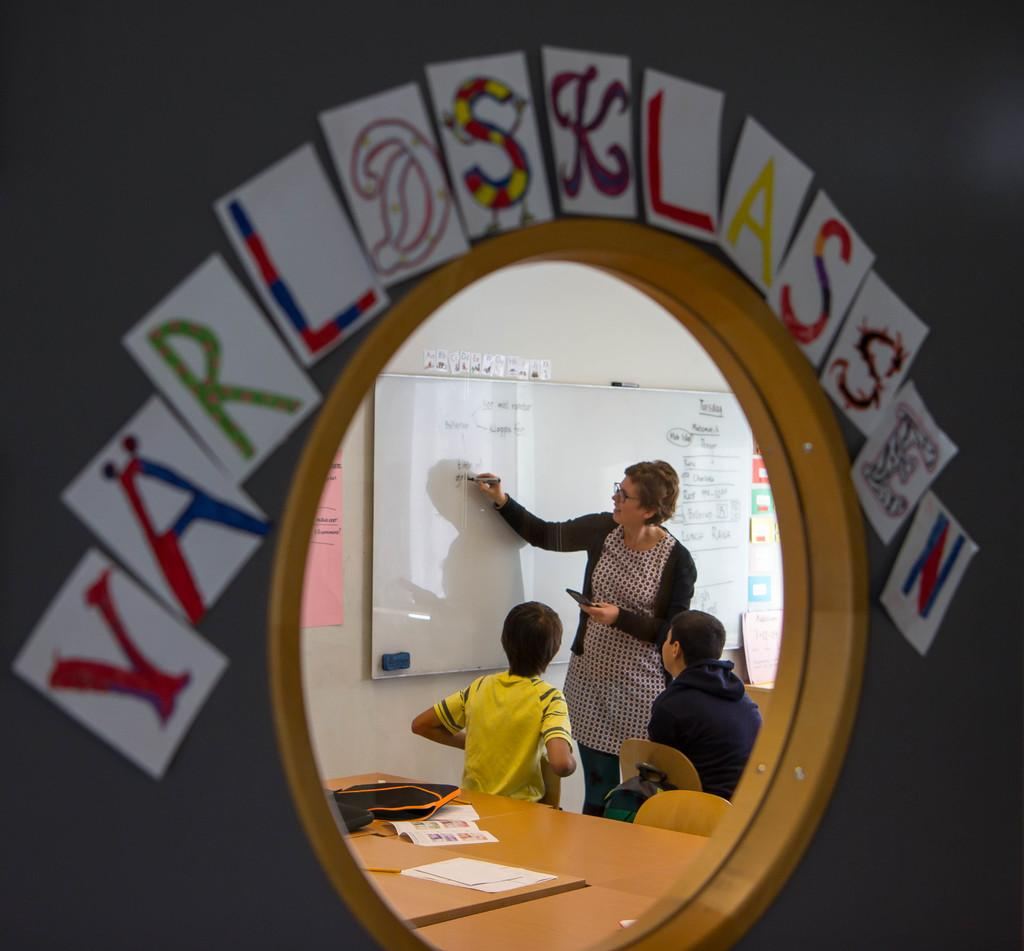How many people are present in the image? There are three people in the image. What is the setting of the image? The image depicts a classroom setting. Who is the central figure in the image? The woman is in the center of the image. What is the woman doing in the image? The woman is writing on a blackboard with a pen. What objects can be seen on the table in the image? There is a paper and a bag on the table. What type of rifle is visible on the table in the image? There is no rifle present in the image; it is a classroom setting with a woman writing on a blackboard and a table with a paper and a bag. What substance is being taught in the image? The image does not specify a particular subject being taught, so it cannot be determined what substance is being taught. 